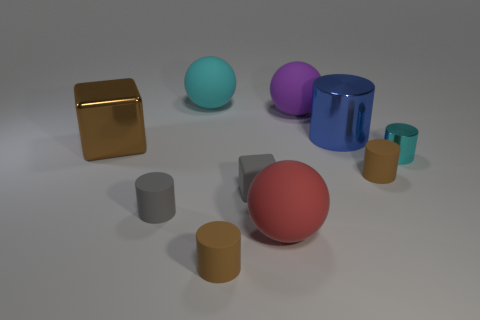Are there any small rubber objects that have the same color as the tiny cube?
Make the answer very short. Yes. What size is the cylinder that is the same color as the small cube?
Keep it short and to the point. Small. There is another thing that is the same color as the tiny metal thing; what is its shape?
Ensure brevity in your answer.  Sphere. Is there any other thing of the same color as the matte cube?
Give a very brief answer. Yes. Is the color of the shiny block the same as the small matte object right of the tiny gray rubber block?
Offer a very short reply. Yes. What material is the cyan cylinder?
Make the answer very short. Metal. There is a tiny rubber block that is behind the large red rubber thing; what is its color?
Your answer should be compact. Gray. How many small objects are the same color as the matte block?
Offer a very short reply. 1. What number of small things are both on the left side of the cyan cylinder and right of the big metal cylinder?
Your response must be concise. 1. There is a brown thing that is the same size as the purple ball; what is its shape?
Keep it short and to the point. Cube. 